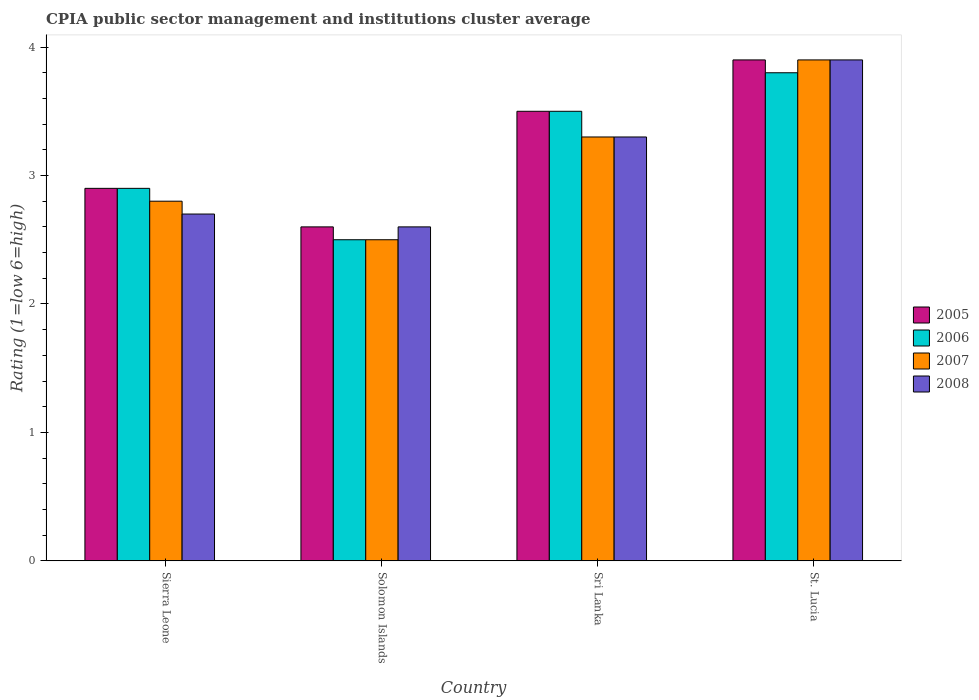How many different coloured bars are there?
Provide a short and direct response. 4. How many groups of bars are there?
Provide a short and direct response. 4. Are the number of bars on each tick of the X-axis equal?
Your response must be concise. Yes. How many bars are there on the 4th tick from the left?
Make the answer very short. 4. How many bars are there on the 2nd tick from the right?
Provide a succinct answer. 4. What is the label of the 4th group of bars from the left?
Keep it short and to the point. St. Lucia. In how many cases, is the number of bars for a given country not equal to the number of legend labels?
Provide a succinct answer. 0. What is the CPIA rating in 2006 in Sri Lanka?
Your answer should be very brief. 3.5. Across all countries, what is the maximum CPIA rating in 2007?
Your response must be concise. 3.9. Across all countries, what is the minimum CPIA rating in 2007?
Offer a very short reply. 2.5. In which country was the CPIA rating in 2006 maximum?
Offer a very short reply. St. Lucia. In which country was the CPIA rating in 2008 minimum?
Make the answer very short. Solomon Islands. What is the total CPIA rating in 2005 in the graph?
Ensure brevity in your answer.  12.9. What is the difference between the CPIA rating in 2005 in Solomon Islands and the CPIA rating in 2008 in Sierra Leone?
Your answer should be very brief. -0.1. What is the average CPIA rating in 2007 per country?
Your answer should be compact. 3.12. What is the ratio of the CPIA rating in 2006 in Sierra Leone to that in Sri Lanka?
Make the answer very short. 0.83. Is the CPIA rating in 2007 in Sri Lanka less than that in St. Lucia?
Ensure brevity in your answer.  Yes. What is the difference between the highest and the second highest CPIA rating in 2006?
Your response must be concise. 0.6. What is the difference between the highest and the lowest CPIA rating in 2006?
Provide a succinct answer. 1.3. In how many countries, is the CPIA rating in 2005 greater than the average CPIA rating in 2005 taken over all countries?
Offer a very short reply. 2. Is the sum of the CPIA rating in 2006 in Sierra Leone and St. Lucia greater than the maximum CPIA rating in 2008 across all countries?
Your answer should be compact. Yes. Is it the case that in every country, the sum of the CPIA rating in 2005 and CPIA rating in 2006 is greater than the sum of CPIA rating in 2008 and CPIA rating in 2007?
Provide a short and direct response. No. What does the 1st bar from the right in Sierra Leone represents?
Provide a succinct answer. 2008. Does the graph contain any zero values?
Provide a succinct answer. No. Does the graph contain grids?
Offer a very short reply. No. Where does the legend appear in the graph?
Provide a short and direct response. Center right. How many legend labels are there?
Your answer should be compact. 4. What is the title of the graph?
Ensure brevity in your answer.  CPIA public sector management and institutions cluster average. What is the Rating (1=low 6=high) of 2006 in Sierra Leone?
Provide a succinct answer. 2.9. What is the Rating (1=low 6=high) of 2007 in Sierra Leone?
Your response must be concise. 2.8. What is the Rating (1=low 6=high) in 2008 in Sierra Leone?
Ensure brevity in your answer.  2.7. What is the Rating (1=low 6=high) of 2006 in Solomon Islands?
Keep it short and to the point. 2.5. What is the Rating (1=low 6=high) of 2006 in Sri Lanka?
Your answer should be compact. 3.5. What is the Rating (1=low 6=high) in 2007 in Sri Lanka?
Your answer should be very brief. 3.3. What is the Rating (1=low 6=high) of 2008 in Sri Lanka?
Offer a terse response. 3.3. What is the Rating (1=low 6=high) of 2005 in St. Lucia?
Keep it short and to the point. 3.9. What is the Rating (1=low 6=high) of 2007 in St. Lucia?
Provide a short and direct response. 3.9. What is the Rating (1=low 6=high) of 2008 in St. Lucia?
Ensure brevity in your answer.  3.9. Across all countries, what is the maximum Rating (1=low 6=high) in 2006?
Ensure brevity in your answer.  3.8. Across all countries, what is the maximum Rating (1=low 6=high) in 2007?
Your response must be concise. 3.9. Across all countries, what is the maximum Rating (1=low 6=high) in 2008?
Keep it short and to the point. 3.9. Across all countries, what is the minimum Rating (1=low 6=high) in 2005?
Keep it short and to the point. 2.6. Across all countries, what is the minimum Rating (1=low 6=high) in 2006?
Provide a short and direct response. 2.5. What is the total Rating (1=low 6=high) of 2007 in the graph?
Ensure brevity in your answer.  12.5. What is the total Rating (1=low 6=high) in 2008 in the graph?
Provide a short and direct response. 12.5. What is the difference between the Rating (1=low 6=high) of 2005 in Sierra Leone and that in Solomon Islands?
Offer a very short reply. 0.3. What is the difference between the Rating (1=low 6=high) of 2007 in Sierra Leone and that in Sri Lanka?
Your response must be concise. -0.5. What is the difference between the Rating (1=low 6=high) in 2005 in Sierra Leone and that in St. Lucia?
Give a very brief answer. -1. What is the difference between the Rating (1=low 6=high) in 2007 in Sierra Leone and that in St. Lucia?
Your response must be concise. -1.1. What is the difference between the Rating (1=low 6=high) of 2006 in Solomon Islands and that in Sri Lanka?
Keep it short and to the point. -1. What is the difference between the Rating (1=low 6=high) in 2007 in Solomon Islands and that in Sri Lanka?
Provide a succinct answer. -0.8. What is the difference between the Rating (1=low 6=high) in 2008 in Solomon Islands and that in Sri Lanka?
Your answer should be very brief. -0.7. What is the difference between the Rating (1=low 6=high) of 2007 in Sierra Leone and the Rating (1=low 6=high) of 2008 in Solomon Islands?
Make the answer very short. 0.2. What is the difference between the Rating (1=low 6=high) of 2005 in Sierra Leone and the Rating (1=low 6=high) of 2006 in Sri Lanka?
Ensure brevity in your answer.  -0.6. What is the difference between the Rating (1=low 6=high) in 2005 in Sierra Leone and the Rating (1=low 6=high) in 2008 in Sri Lanka?
Your answer should be compact. -0.4. What is the difference between the Rating (1=low 6=high) in 2006 in Sierra Leone and the Rating (1=low 6=high) in 2007 in Sri Lanka?
Keep it short and to the point. -0.4. What is the difference between the Rating (1=low 6=high) of 2006 in Sierra Leone and the Rating (1=low 6=high) of 2008 in Sri Lanka?
Keep it short and to the point. -0.4. What is the difference between the Rating (1=low 6=high) of 2005 in Sierra Leone and the Rating (1=low 6=high) of 2006 in St. Lucia?
Your answer should be very brief. -0.9. What is the difference between the Rating (1=low 6=high) in 2005 in Sierra Leone and the Rating (1=low 6=high) in 2008 in St. Lucia?
Keep it short and to the point. -1. What is the difference between the Rating (1=low 6=high) in 2006 in Sierra Leone and the Rating (1=low 6=high) in 2008 in St. Lucia?
Your response must be concise. -1. What is the difference between the Rating (1=low 6=high) of 2007 in Sierra Leone and the Rating (1=low 6=high) of 2008 in St. Lucia?
Keep it short and to the point. -1.1. What is the difference between the Rating (1=low 6=high) in 2005 in Solomon Islands and the Rating (1=low 6=high) in 2007 in Sri Lanka?
Offer a terse response. -0.7. What is the difference between the Rating (1=low 6=high) of 2005 in Solomon Islands and the Rating (1=low 6=high) of 2006 in St. Lucia?
Your response must be concise. -1.2. What is the difference between the Rating (1=low 6=high) of 2006 in Solomon Islands and the Rating (1=low 6=high) of 2008 in St. Lucia?
Offer a terse response. -1.4. What is the difference between the Rating (1=low 6=high) of 2005 in Sri Lanka and the Rating (1=low 6=high) of 2006 in St. Lucia?
Offer a very short reply. -0.3. What is the difference between the Rating (1=low 6=high) in 2005 in Sri Lanka and the Rating (1=low 6=high) in 2007 in St. Lucia?
Ensure brevity in your answer.  -0.4. What is the difference between the Rating (1=low 6=high) of 2005 in Sri Lanka and the Rating (1=low 6=high) of 2008 in St. Lucia?
Your response must be concise. -0.4. What is the difference between the Rating (1=low 6=high) of 2007 in Sri Lanka and the Rating (1=low 6=high) of 2008 in St. Lucia?
Offer a terse response. -0.6. What is the average Rating (1=low 6=high) in 2005 per country?
Your answer should be compact. 3.23. What is the average Rating (1=low 6=high) of 2006 per country?
Your answer should be very brief. 3.17. What is the average Rating (1=low 6=high) of 2007 per country?
Give a very brief answer. 3.12. What is the average Rating (1=low 6=high) of 2008 per country?
Provide a succinct answer. 3.12. What is the difference between the Rating (1=low 6=high) of 2005 and Rating (1=low 6=high) of 2008 in Sierra Leone?
Offer a terse response. 0.2. What is the difference between the Rating (1=low 6=high) of 2007 and Rating (1=low 6=high) of 2008 in Sierra Leone?
Ensure brevity in your answer.  0.1. What is the difference between the Rating (1=low 6=high) in 2005 and Rating (1=low 6=high) in 2006 in Solomon Islands?
Give a very brief answer. 0.1. What is the difference between the Rating (1=low 6=high) in 2005 and Rating (1=low 6=high) in 2008 in Solomon Islands?
Make the answer very short. 0. What is the difference between the Rating (1=low 6=high) of 2006 and Rating (1=low 6=high) of 2008 in Solomon Islands?
Your answer should be compact. -0.1. What is the difference between the Rating (1=low 6=high) in 2007 and Rating (1=low 6=high) in 2008 in Solomon Islands?
Provide a succinct answer. -0.1. What is the difference between the Rating (1=low 6=high) in 2006 and Rating (1=low 6=high) in 2008 in Sri Lanka?
Your answer should be very brief. 0.2. What is the difference between the Rating (1=low 6=high) of 2007 and Rating (1=low 6=high) of 2008 in Sri Lanka?
Make the answer very short. 0. What is the difference between the Rating (1=low 6=high) in 2005 and Rating (1=low 6=high) in 2008 in St. Lucia?
Offer a very short reply. 0. What is the ratio of the Rating (1=low 6=high) of 2005 in Sierra Leone to that in Solomon Islands?
Give a very brief answer. 1.12. What is the ratio of the Rating (1=low 6=high) in 2006 in Sierra Leone to that in Solomon Islands?
Your answer should be compact. 1.16. What is the ratio of the Rating (1=low 6=high) in 2007 in Sierra Leone to that in Solomon Islands?
Provide a succinct answer. 1.12. What is the ratio of the Rating (1=low 6=high) in 2008 in Sierra Leone to that in Solomon Islands?
Offer a very short reply. 1.04. What is the ratio of the Rating (1=low 6=high) of 2005 in Sierra Leone to that in Sri Lanka?
Provide a short and direct response. 0.83. What is the ratio of the Rating (1=low 6=high) in 2006 in Sierra Leone to that in Sri Lanka?
Offer a very short reply. 0.83. What is the ratio of the Rating (1=low 6=high) in 2007 in Sierra Leone to that in Sri Lanka?
Provide a short and direct response. 0.85. What is the ratio of the Rating (1=low 6=high) of 2008 in Sierra Leone to that in Sri Lanka?
Your answer should be compact. 0.82. What is the ratio of the Rating (1=low 6=high) in 2005 in Sierra Leone to that in St. Lucia?
Provide a succinct answer. 0.74. What is the ratio of the Rating (1=low 6=high) in 2006 in Sierra Leone to that in St. Lucia?
Make the answer very short. 0.76. What is the ratio of the Rating (1=low 6=high) of 2007 in Sierra Leone to that in St. Lucia?
Give a very brief answer. 0.72. What is the ratio of the Rating (1=low 6=high) of 2008 in Sierra Leone to that in St. Lucia?
Offer a terse response. 0.69. What is the ratio of the Rating (1=low 6=high) in 2005 in Solomon Islands to that in Sri Lanka?
Offer a terse response. 0.74. What is the ratio of the Rating (1=low 6=high) of 2006 in Solomon Islands to that in Sri Lanka?
Ensure brevity in your answer.  0.71. What is the ratio of the Rating (1=low 6=high) of 2007 in Solomon Islands to that in Sri Lanka?
Offer a terse response. 0.76. What is the ratio of the Rating (1=low 6=high) of 2008 in Solomon Islands to that in Sri Lanka?
Ensure brevity in your answer.  0.79. What is the ratio of the Rating (1=low 6=high) of 2005 in Solomon Islands to that in St. Lucia?
Your response must be concise. 0.67. What is the ratio of the Rating (1=low 6=high) of 2006 in Solomon Islands to that in St. Lucia?
Make the answer very short. 0.66. What is the ratio of the Rating (1=low 6=high) in 2007 in Solomon Islands to that in St. Lucia?
Your response must be concise. 0.64. What is the ratio of the Rating (1=low 6=high) in 2008 in Solomon Islands to that in St. Lucia?
Your answer should be compact. 0.67. What is the ratio of the Rating (1=low 6=high) of 2005 in Sri Lanka to that in St. Lucia?
Your answer should be compact. 0.9. What is the ratio of the Rating (1=low 6=high) in 2006 in Sri Lanka to that in St. Lucia?
Your answer should be compact. 0.92. What is the ratio of the Rating (1=low 6=high) of 2007 in Sri Lanka to that in St. Lucia?
Give a very brief answer. 0.85. What is the ratio of the Rating (1=low 6=high) in 2008 in Sri Lanka to that in St. Lucia?
Give a very brief answer. 0.85. What is the difference between the highest and the second highest Rating (1=low 6=high) in 2005?
Your answer should be compact. 0.4. What is the difference between the highest and the lowest Rating (1=low 6=high) in 2006?
Make the answer very short. 1.3. What is the difference between the highest and the lowest Rating (1=low 6=high) in 2007?
Your response must be concise. 1.4. 